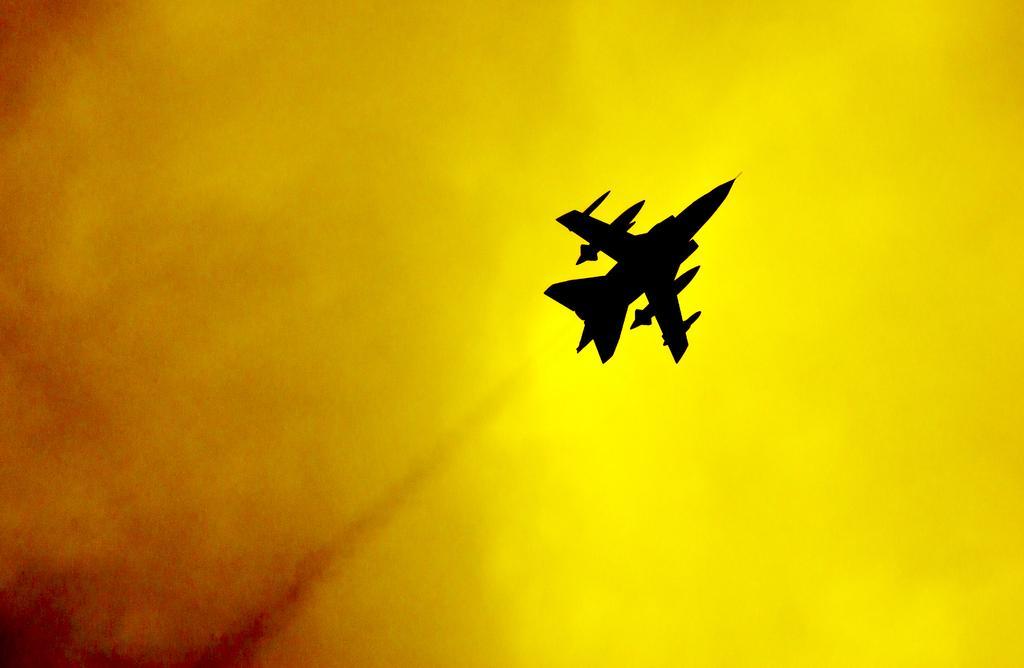Describe this image in one or two sentences. In this image we can see a jet in the sky. 